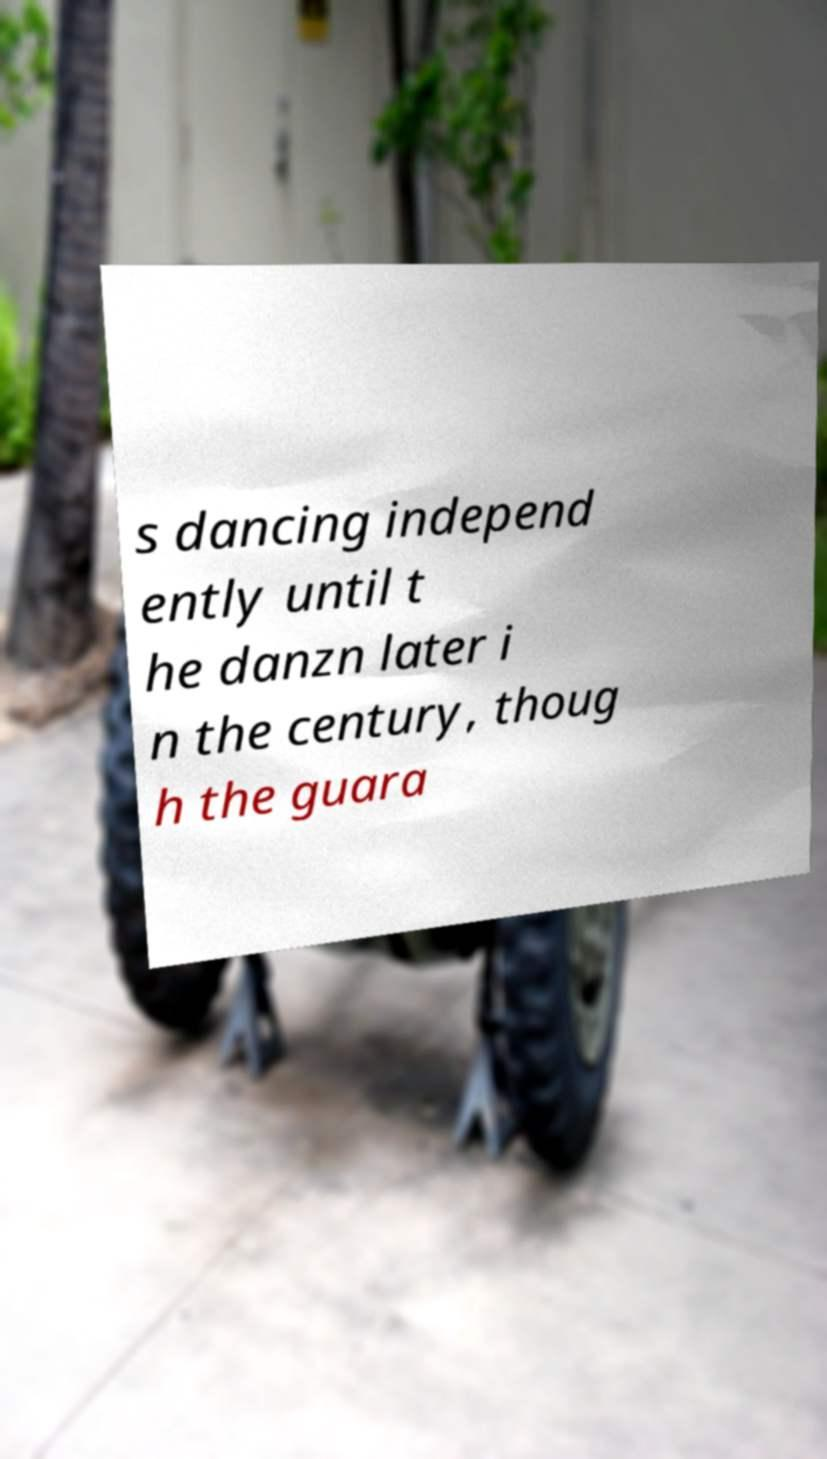For documentation purposes, I need the text within this image transcribed. Could you provide that? s dancing independ ently until t he danzn later i n the century, thoug h the guara 